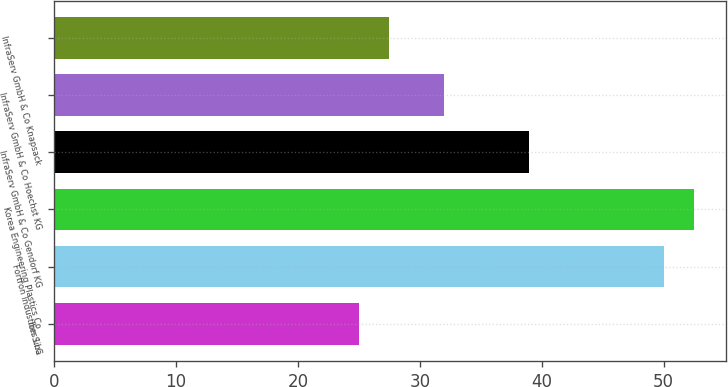<chart> <loc_0><loc_0><loc_500><loc_500><bar_chart><fcel>Ibn Sina<fcel>Fortron Industries LLC<fcel>Korea Engineering Plastics Co<fcel>InfraServ GmbH & Co Gendorf KG<fcel>InfraServ GmbH & Co Hoechst KG<fcel>InfraServ GmbH & Co Knapsack<nl><fcel>25<fcel>50<fcel>52.5<fcel>39<fcel>32<fcel>27.5<nl></chart> 